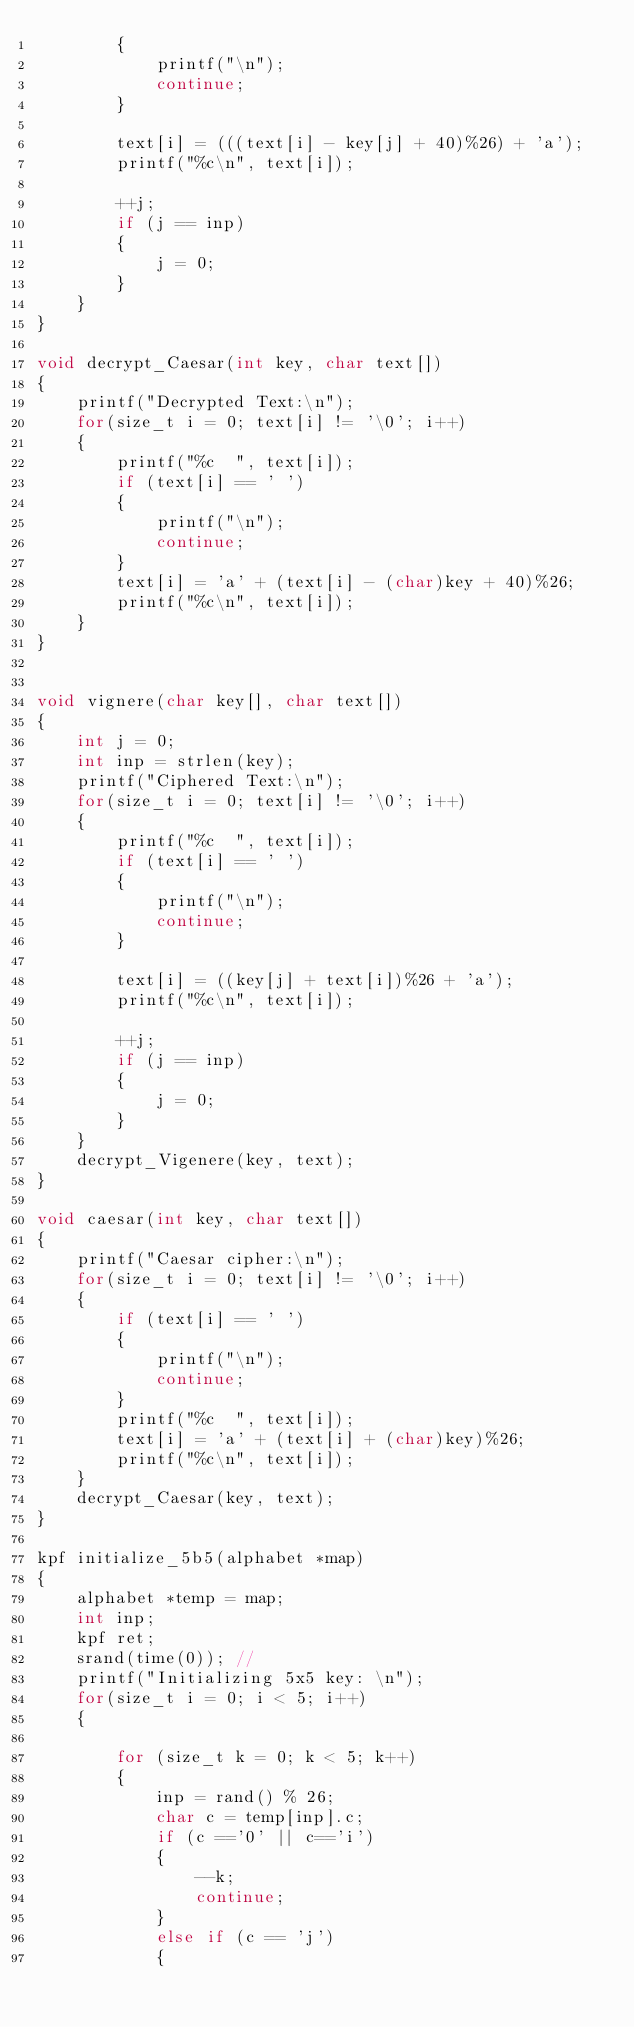Convert code to text. <code><loc_0><loc_0><loc_500><loc_500><_C_>        {
            printf("\n");
            continue;
        }

        text[i] = (((text[i] - key[j] + 40)%26) + 'a');
        printf("%c\n", text[i]);

        ++j;
        if (j == inp)
        {
            j = 0;
        }
    }
}

void decrypt_Caesar(int key, char text[])
{
    printf("Decrypted Text:\n");
    for(size_t i = 0; text[i] != '\0'; i++)
    {
        printf("%c  ", text[i]);
        if (text[i] == ' ')
        {
            printf("\n");
            continue;
        }
        text[i] = 'a' + (text[i] - (char)key + 40)%26; 
        printf("%c\n", text[i]);  
    }
}


void vignere(char key[], char text[])
{
    int j = 0;
    int inp = strlen(key);
    printf("Ciphered Text:\n");
    for(size_t i = 0; text[i] != '\0'; i++)
    {
        printf("%c  ", text[i]);
        if (text[i] == ' ')
        {
            printf("\n");
            continue;
        }

        text[i] = ((key[j] + text[i])%26 + 'a');
        printf("%c\n", text[i]);

        ++j;
        if (j == inp)
        {
            j = 0;
        }
    }
    decrypt_Vigenere(key, text);
}

void caesar(int key, char text[])
{
    printf("Caesar cipher:\n");
    for(size_t i = 0; text[i] != '\0'; i++)
    {
        if (text[i] == ' ')
        {
            printf("\n");
            continue;
        }
        printf("%c  ", text[i]);
        text[i] = 'a' + (text[i] + (char)key)%26;
        printf("%c\n", text[i]);
    }
    decrypt_Caesar(key, text);
}

kpf initialize_5b5(alphabet *map)
{
    alphabet *temp = map;
    int inp;
    kpf ret;
    srand(time(0)); //
    printf("Initializing 5x5 key: \n");
    for(size_t i = 0; i < 5; i++)
    {
        
        for (size_t k = 0; k < 5; k++)
        {
            inp = rand() % 26;
            char c = temp[inp].c;
            if (c =='0' || c=='i')
            {
                --k;
                continue;
            }
            else if (c == 'j')
            {</code> 